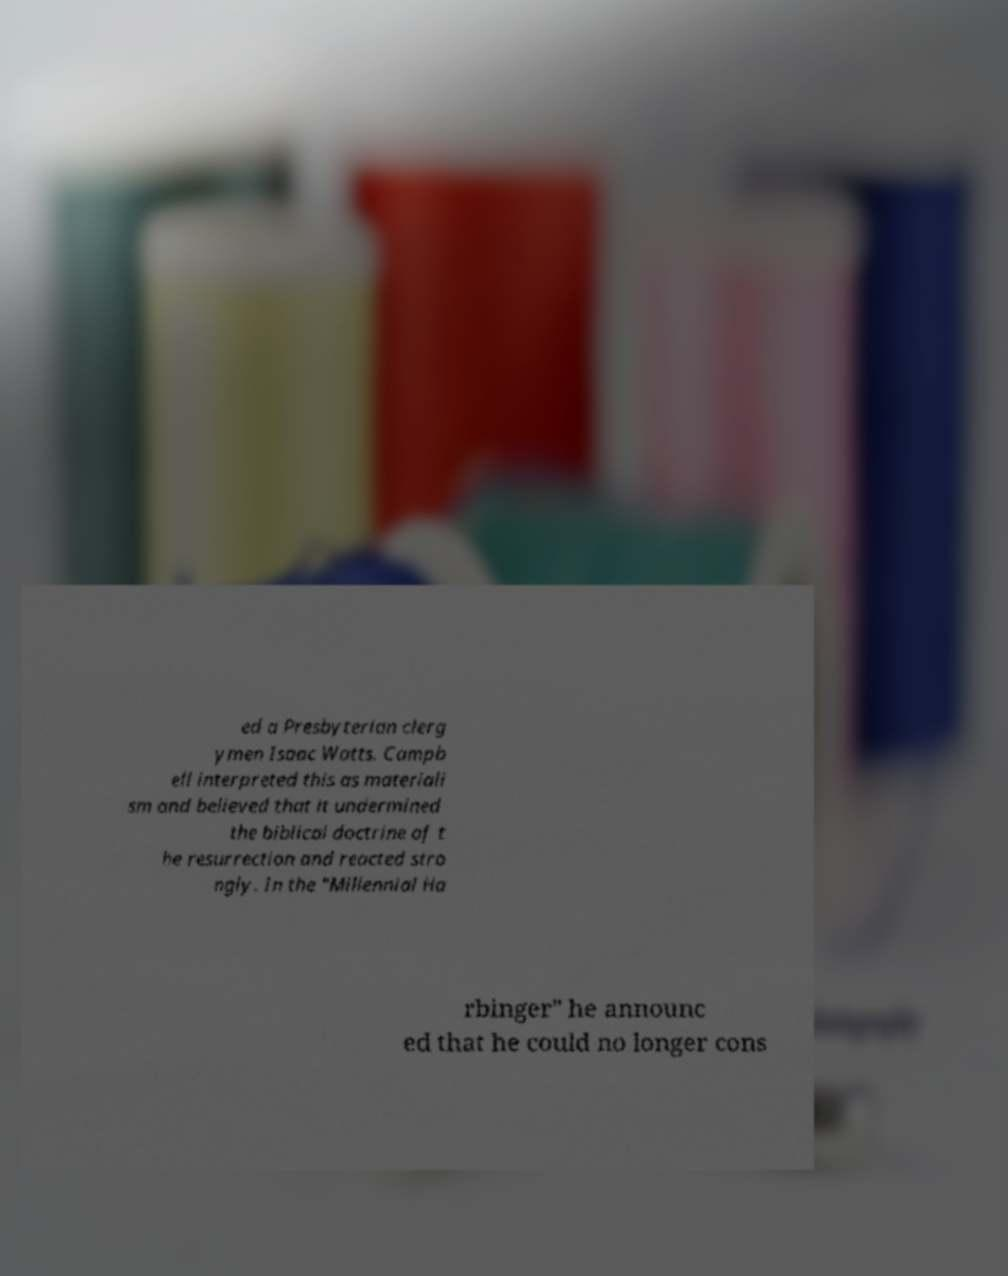There's text embedded in this image that I need extracted. Can you transcribe it verbatim? ed a Presbyterian clerg ymen Isaac Watts. Campb ell interpreted this as materiali sm and believed that it undermined the biblical doctrine of t he resurrection and reacted stro ngly. In the "Millennial Ha rbinger" he announc ed that he could no longer cons 